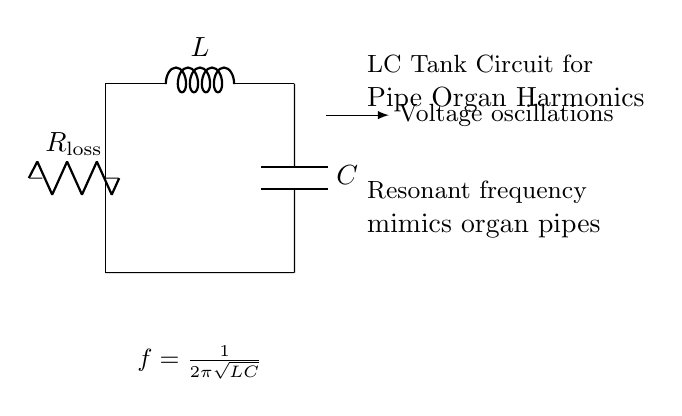What are the components of this circuit? The circuit consists of an inductor labeled 'L', a capacitor labeled 'C', and a resistor labeled 'R_loss'. These components can be visually identified in the diagram.
Answer: Inductor, capacitor, resistor What does the equation represent? The equation f = 1/(2π√(LC)) represents the resonant frequency of the LC tank circuit. This frequency determines how the circuit will respond in terms of oscillations and is derived from the characteristics of the inductor and capacitor.
Answer: Resonant frequency What is the purpose of the resistor in this circuit? The resistor labeled 'R_loss' accounts for the energy losses within the circuit, which can occur due to resistance in the components or other losses in the system. It is essential for understanding how realistic oscillations will be in this theoretical model.
Answer: Energy losses What is the relationship between resonant frequency and organ pipes? The diagram indicates that the resonant frequency mimics organ pipes, suggesting that these frequencies can reproduce sound characteristics similar to those produced by actual pipe organs. This highlights the relevance of the circuit in a musical context.
Answer: Mimics organ pipes What are the voltage oscillations described in the circuit? The voltage oscillations are the result of the energy transfer between the inductor and capacitor, creating alternating current. The circuit's design allows these oscillations to occur at a defined resonant frequency, contributing to the sound reproduction of the pipe organs.
Answer: Voltage oscillations 